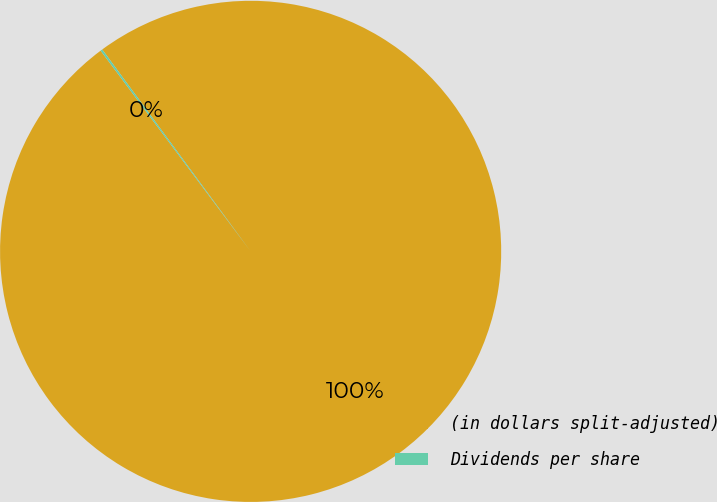Convert chart to OTSL. <chart><loc_0><loc_0><loc_500><loc_500><pie_chart><fcel>(in dollars split-adjusted)<fcel>Dividends per share<nl><fcel>99.87%<fcel>0.13%<nl></chart> 